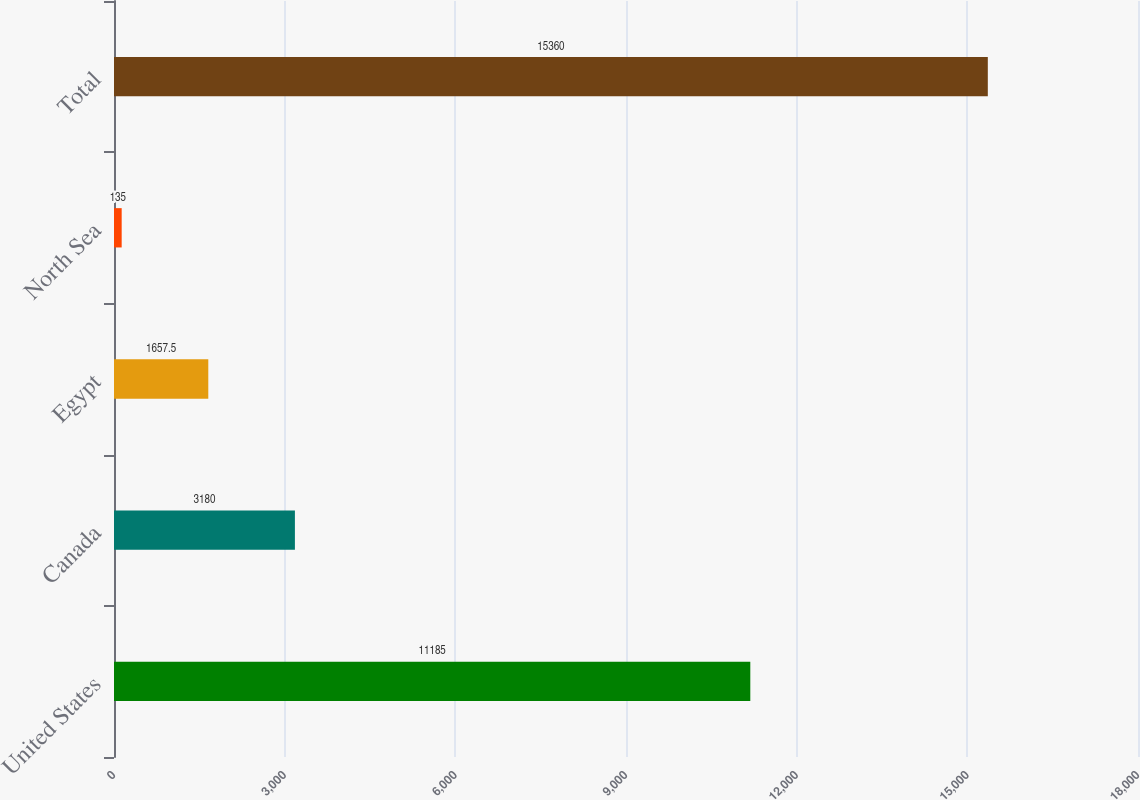<chart> <loc_0><loc_0><loc_500><loc_500><bar_chart><fcel>United States<fcel>Canada<fcel>Egypt<fcel>North Sea<fcel>Total<nl><fcel>11185<fcel>3180<fcel>1657.5<fcel>135<fcel>15360<nl></chart> 